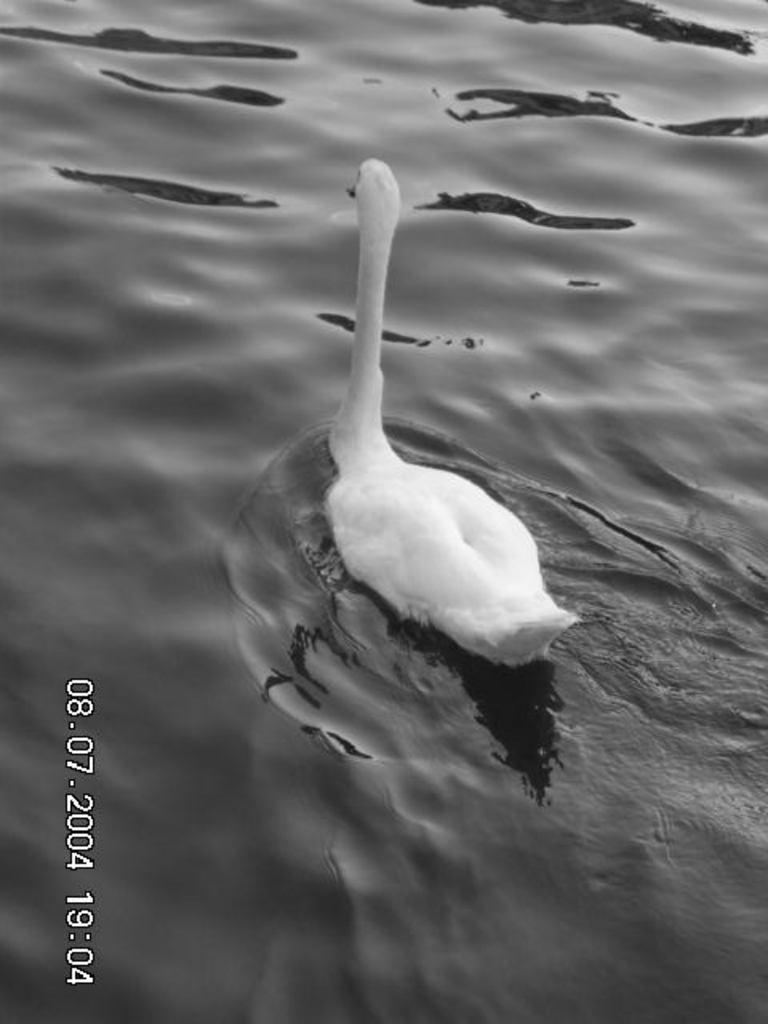Please provide a concise description of this image. In this image there is a swan swimming on the water. To the left there are numbers on the image. 